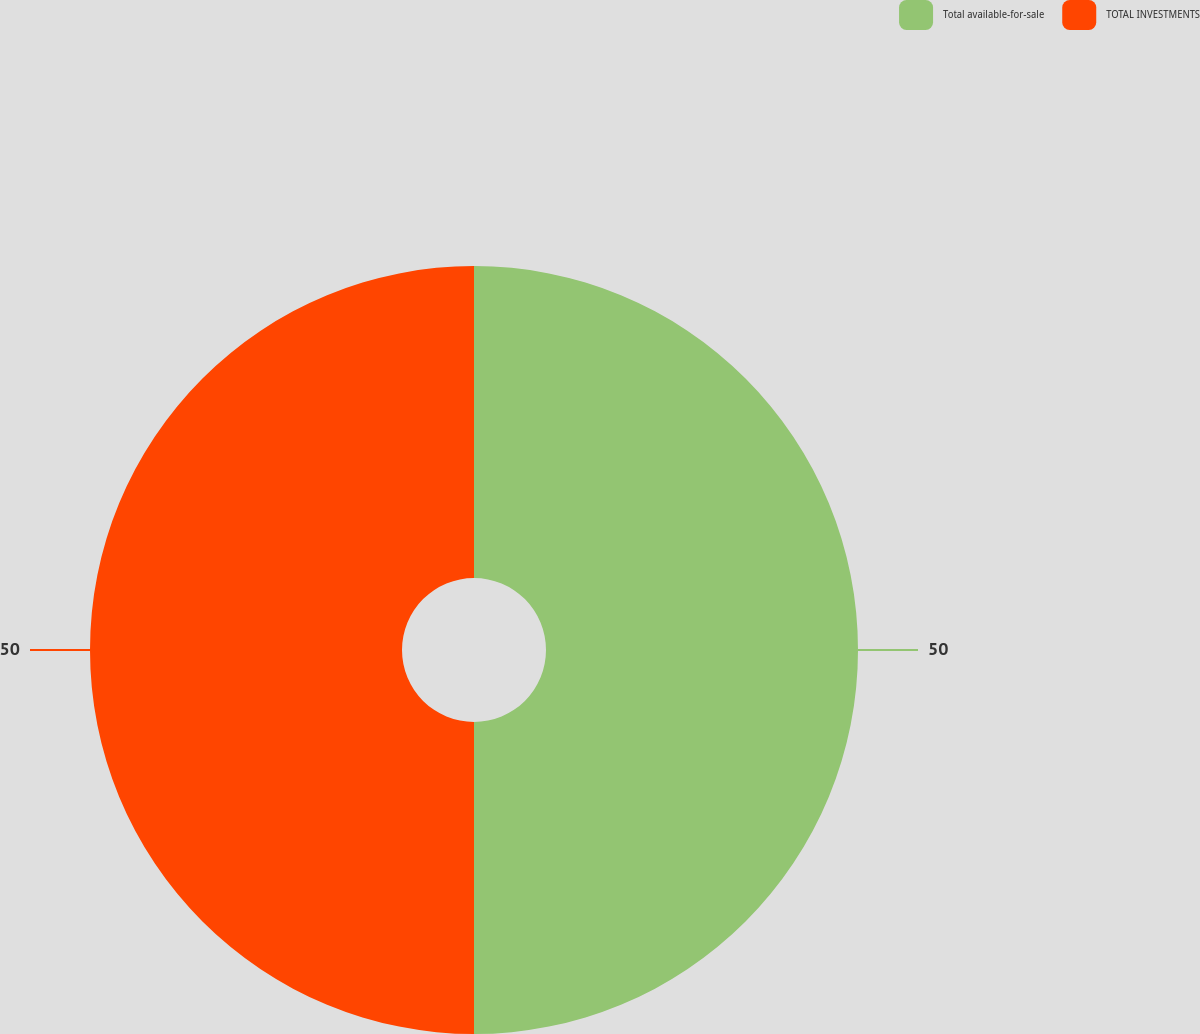Convert chart to OTSL. <chart><loc_0><loc_0><loc_500><loc_500><pie_chart><fcel>Total available-for-sale<fcel>TOTAL INVESTMENTS<nl><fcel>50.0%<fcel>50.0%<nl></chart> 